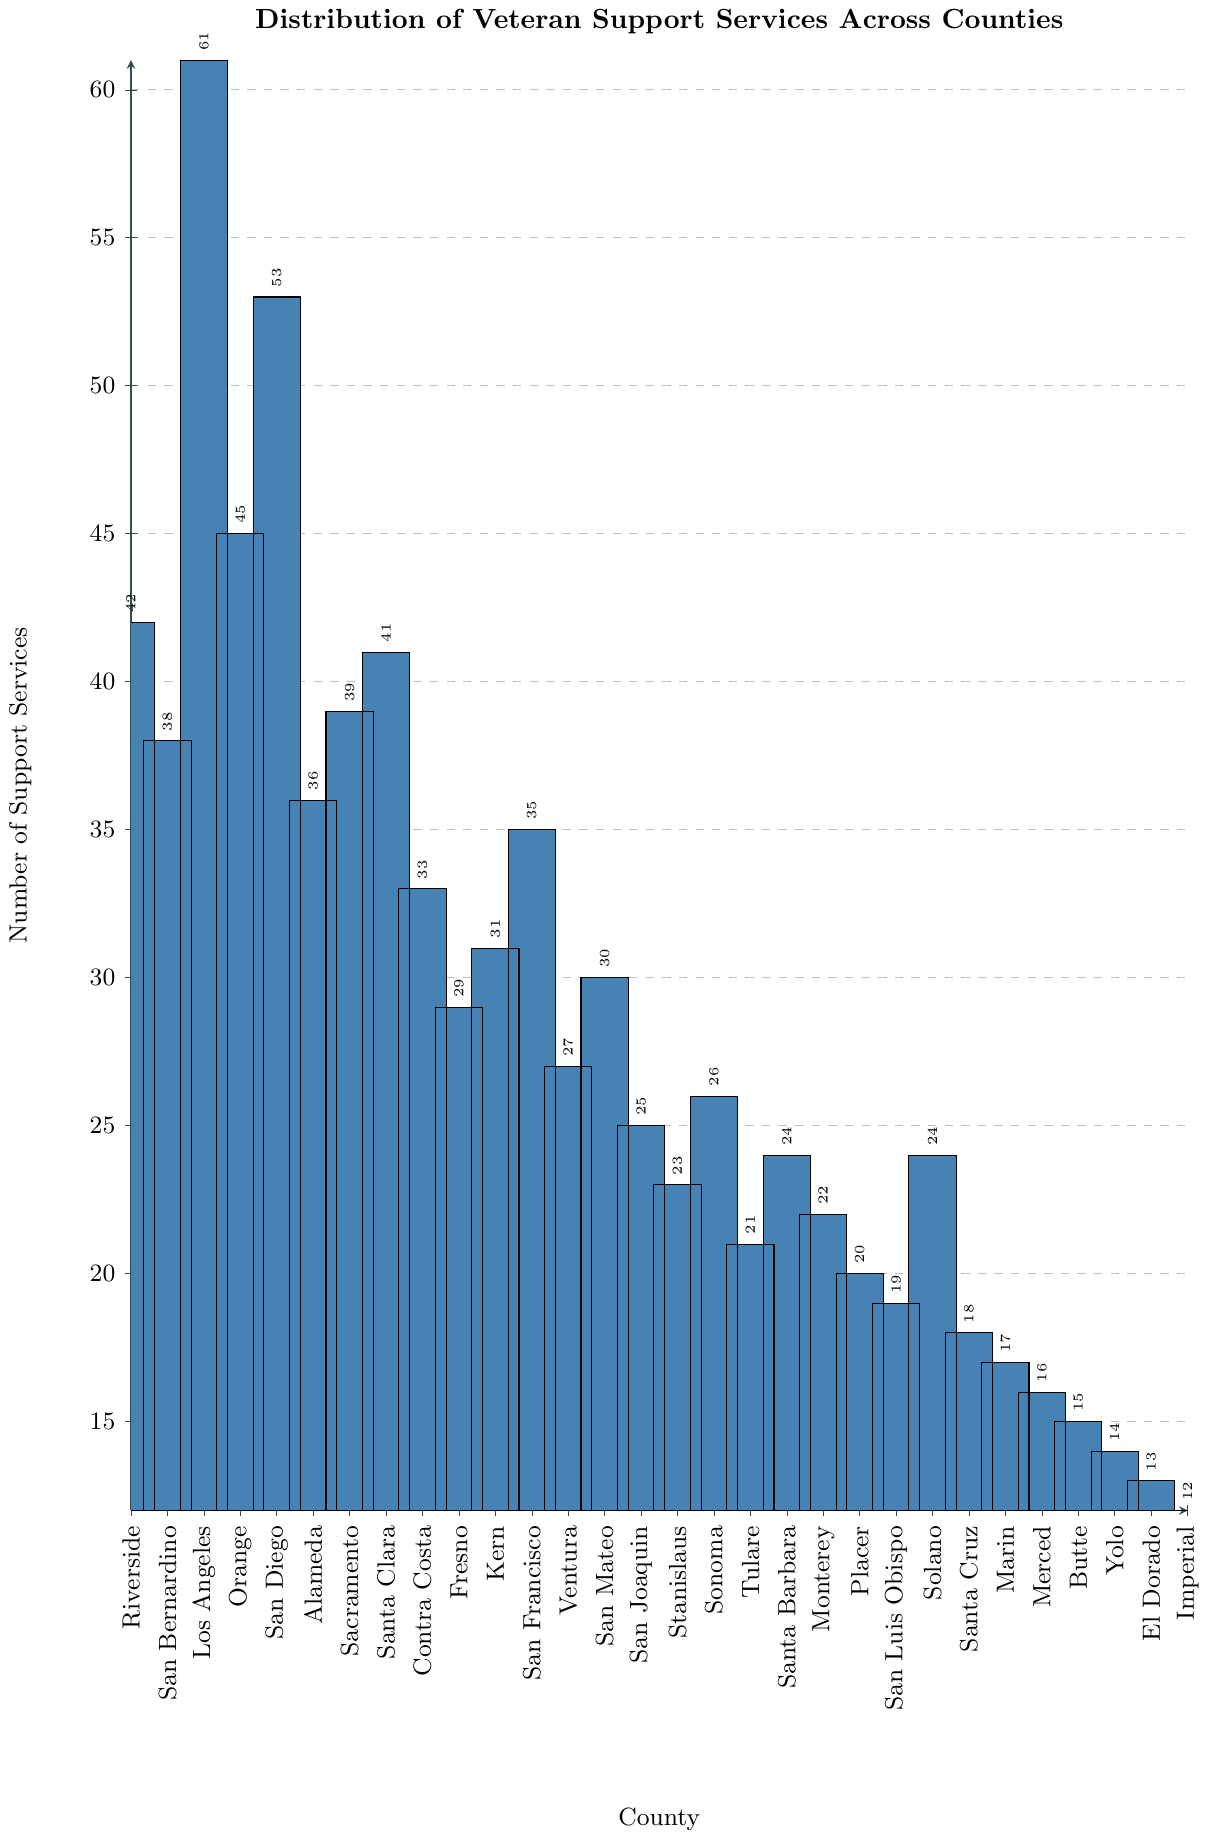Which county has the highest number of veteran support services? Look at the bar with the greatest height. Los Angeles has the tallest bar.
Answer: Los Angeles Which three counties have the lowest number of veteran support services? Identify the three shortest bars. They belong to Yolo, El Dorado, and Imperial.
Answer: Yolo, El Dorado, Imperial How many more veteran support services does Los Angeles have compared to Ventura? Find the values for Los Angeles and Ventura. Los Angeles has 61 and Ventura has 27. Calculate the difference: 61 - 27 = 34
Answer: 34 What is the total number of veteran support services in Riverside, San Bernardino, and Los Angeles combined? Add the values for Riverside (42), San Bernardino (38), and Los Angeles (61). 42 + 38 + 61 = 141
Answer: 141 What is the average number of veteran support services across all the counties? Sum all the values and divide by the number of counties (30). The sum is 904, so the average is 904 / 30 = 30.13
Answer: 30.13 Is the number of veteran support services in Santa Clara greater than in Fresno? Compare the heights of the bars for Santa Clara and Fresno. Santa Clara has 41 and Fresno has 29, so 41 > 29.
Answer: Yes How many counties have more than 40 veteran support services? Count the number of bars with height greater than 40. Riverside, Los Angeles, Orange, and San Diego.
Answer: 4 Which county has five fewer veteran support services than Sacramento? Sacramento has 39 veteran support services. Find a county with 34 services. San Francisco fits this criterion.
Answer: San Francisco What is the combined number of veteran support services for counties starting with 'San'? Sum the values for San Bernardino (38), San Diego (53), San Francisco (35), San Mateo (30), San Joaquin (25), and San Luis Obispo (19). 38 + 53 + 35 + 30 + 25 + 19 = 200
Answer: 200 